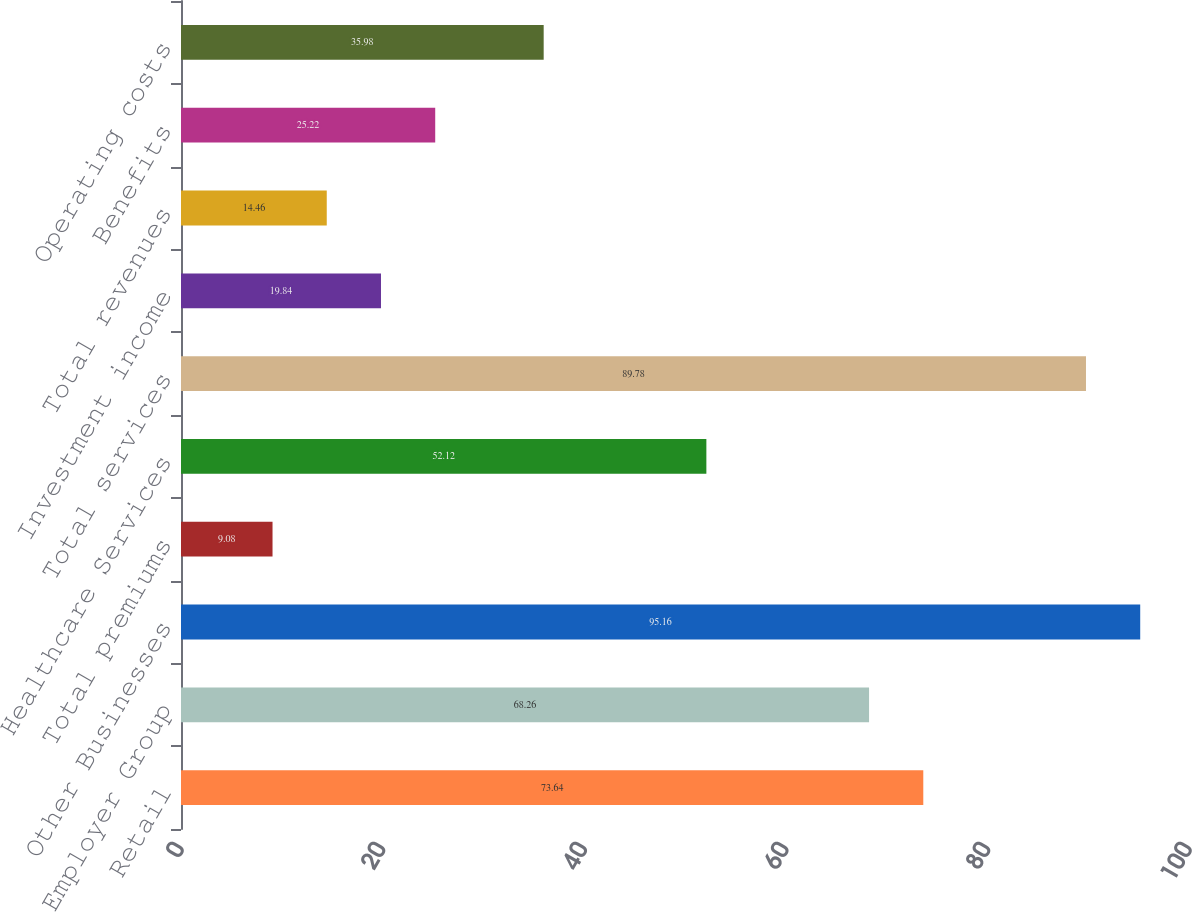Convert chart. <chart><loc_0><loc_0><loc_500><loc_500><bar_chart><fcel>Retail<fcel>Employer Group<fcel>Other Businesses<fcel>Total premiums<fcel>Healthcare Services<fcel>Total services<fcel>Investment income<fcel>Total revenues<fcel>Benefits<fcel>Operating costs<nl><fcel>73.64<fcel>68.26<fcel>95.16<fcel>9.08<fcel>52.12<fcel>89.78<fcel>19.84<fcel>14.46<fcel>25.22<fcel>35.98<nl></chart> 